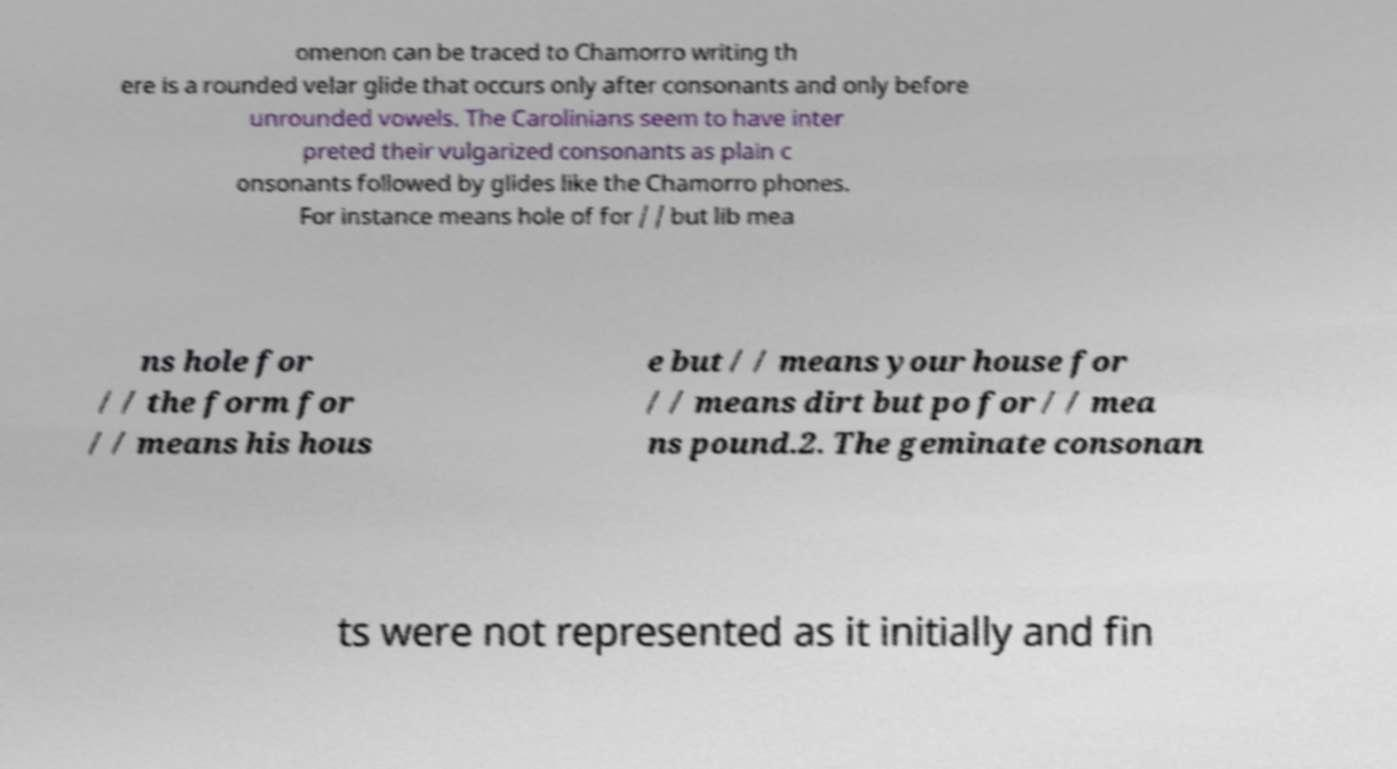I need the written content from this picture converted into text. Can you do that? omenon can be traced to Chamorro writing th ere is a rounded velar glide that occurs only after consonants and only before unrounded vowels. The Carolinians seem to have inter preted their vulgarized consonants as plain c onsonants followed by glides like the Chamorro phones. For instance means hole of for / / but lib mea ns hole for / / the form for / / means his hous e but / / means your house for / / means dirt but po for / / mea ns pound.2. The geminate consonan ts were not represented as it initially and fin 